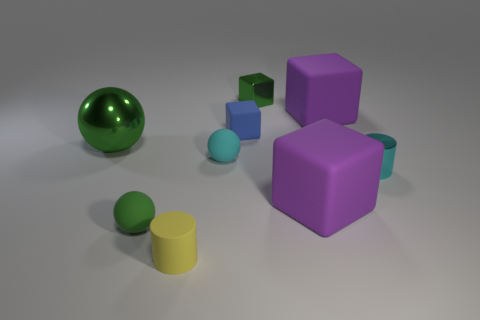Add 1 tiny red rubber cylinders. How many objects exist? 10 Subtract all spheres. How many objects are left? 6 Subtract all blue rubber cubes. Subtract all small gray metal cylinders. How many objects are left? 8 Add 8 cyan shiny objects. How many cyan shiny objects are left? 9 Add 5 tiny gray matte cubes. How many tiny gray matte cubes exist? 5 Subtract 0 purple spheres. How many objects are left? 9 